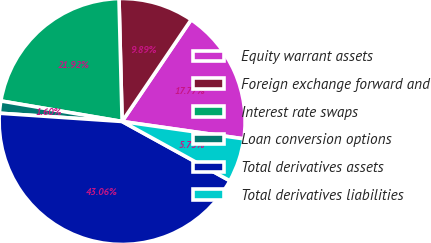Convert chart to OTSL. <chart><loc_0><loc_0><loc_500><loc_500><pie_chart><fcel>Equity warrant assets<fcel>Foreign exchange forward and<fcel>Interest rate swaps<fcel>Loan conversion options<fcel>Total derivatives assets<fcel>Total derivatives liabilities<nl><fcel>17.77%<fcel>9.89%<fcel>21.92%<fcel>1.6%<fcel>43.06%<fcel>5.75%<nl></chart> 